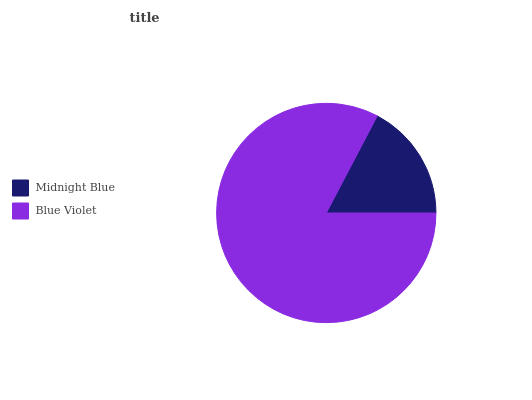Is Midnight Blue the minimum?
Answer yes or no. Yes. Is Blue Violet the maximum?
Answer yes or no. Yes. Is Blue Violet the minimum?
Answer yes or no. No. Is Blue Violet greater than Midnight Blue?
Answer yes or no. Yes. Is Midnight Blue less than Blue Violet?
Answer yes or no. Yes. Is Midnight Blue greater than Blue Violet?
Answer yes or no. No. Is Blue Violet less than Midnight Blue?
Answer yes or no. No. Is Blue Violet the high median?
Answer yes or no. Yes. Is Midnight Blue the low median?
Answer yes or no. Yes. Is Midnight Blue the high median?
Answer yes or no. No. Is Blue Violet the low median?
Answer yes or no. No. 